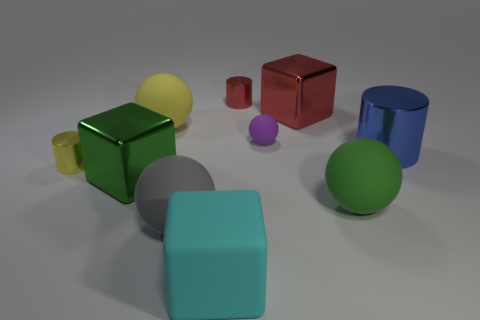What number of objects are either tiny brown metallic things or small cylinders that are on the right side of the large cyan matte thing?
Offer a terse response. 1. What size is the cylinder that is on the left side of the big cyan rubber block?
Offer a very short reply. Small. Is the number of tiny balls on the right side of the blue metallic cylinder less than the number of yellow matte spheres behind the big yellow object?
Make the answer very short. No. There is a big thing that is behind the yellow metallic cylinder and on the right side of the large red cube; what material is it?
Offer a very short reply. Metal. There is a big matte thing that is behind the large shiny block to the left of the yellow ball; what shape is it?
Provide a short and direct response. Sphere. Does the big matte cube have the same color as the small rubber ball?
Your response must be concise. No. What number of purple things are tiny matte objects or large rubber blocks?
Give a very brief answer. 1. Are there any large shiny blocks in front of the big blue cylinder?
Ensure brevity in your answer.  Yes. What is the size of the yellow ball?
Provide a short and direct response. Large. What size is the purple matte object that is the same shape as the large green matte thing?
Offer a terse response. Small. 